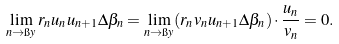Convert formula to latex. <formula><loc_0><loc_0><loc_500><loc_500>\lim _ { n \to \i y } r _ { n } u _ { n } u _ { n + 1 } \Delta \beta _ { n } = \lim _ { n \to \i y } ( r _ { n } v _ { n } u _ { n + 1 } \Delta \beta _ { n } ) \cdot \frac { u _ { n } } { v _ { n } } = 0 .</formula> 